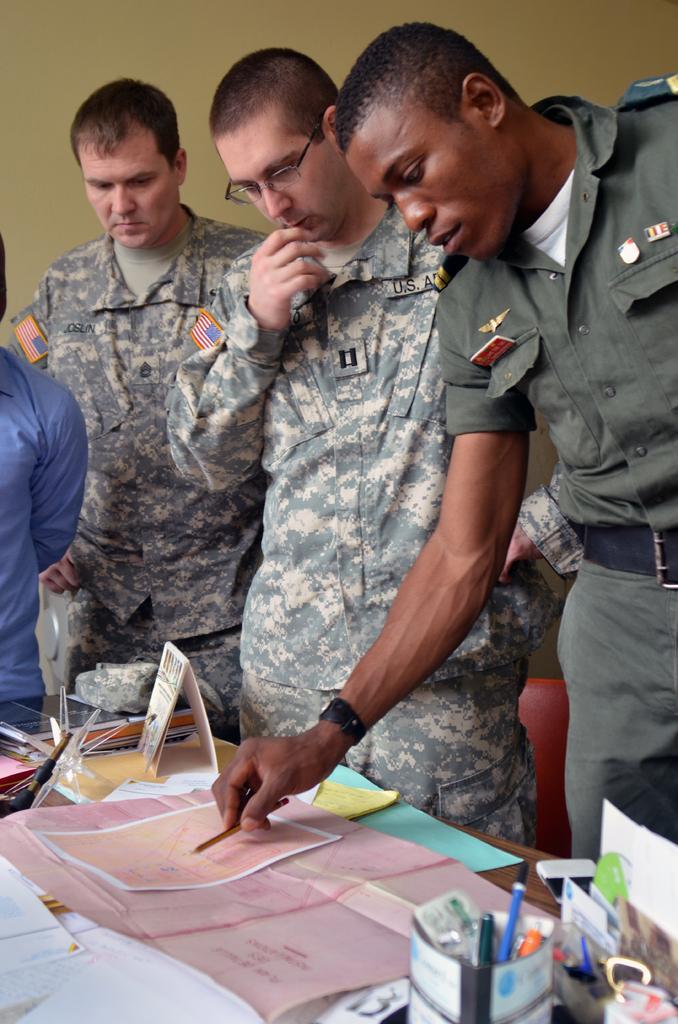Can you describe this image briefly? In this picture there are men in the center of the image, it seems to be they are soldiers. 